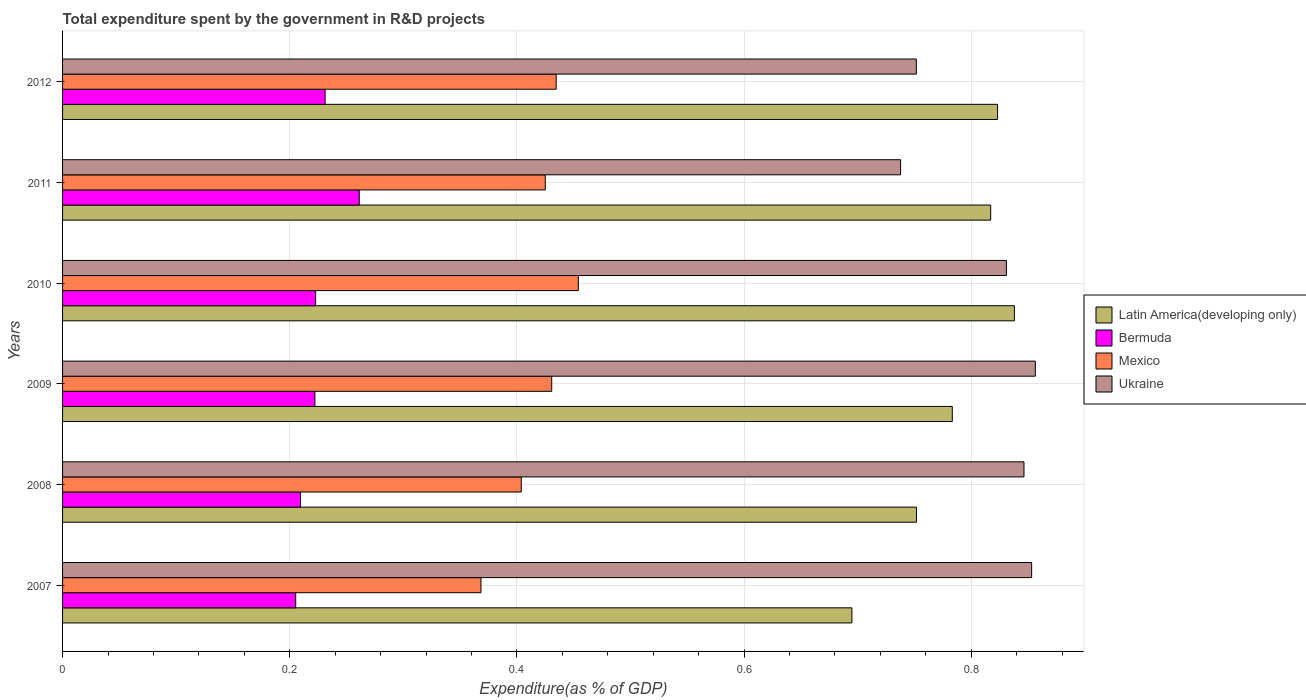How many different coloured bars are there?
Ensure brevity in your answer.  4. How many groups of bars are there?
Make the answer very short. 6. Are the number of bars per tick equal to the number of legend labels?
Offer a terse response. Yes. How many bars are there on the 3rd tick from the top?
Offer a terse response. 4. What is the total expenditure spent by the government in R&D projects in Mexico in 2011?
Your answer should be compact. 0.42. Across all years, what is the maximum total expenditure spent by the government in R&D projects in Mexico?
Your response must be concise. 0.45. Across all years, what is the minimum total expenditure spent by the government in R&D projects in Latin America(developing only)?
Your answer should be compact. 0.69. In which year was the total expenditure spent by the government in R&D projects in Mexico minimum?
Give a very brief answer. 2007. What is the total total expenditure spent by the government in R&D projects in Ukraine in the graph?
Keep it short and to the point. 4.88. What is the difference between the total expenditure spent by the government in R&D projects in Ukraine in 2009 and that in 2011?
Offer a terse response. 0.12. What is the difference between the total expenditure spent by the government in R&D projects in Mexico in 2007 and the total expenditure spent by the government in R&D projects in Ukraine in 2012?
Your response must be concise. -0.38. What is the average total expenditure spent by the government in R&D projects in Mexico per year?
Ensure brevity in your answer.  0.42. In the year 2008, what is the difference between the total expenditure spent by the government in R&D projects in Bermuda and total expenditure spent by the government in R&D projects in Latin America(developing only)?
Your answer should be compact. -0.54. In how many years, is the total expenditure spent by the government in R&D projects in Latin America(developing only) greater than 0.36 %?
Give a very brief answer. 6. What is the ratio of the total expenditure spent by the government in R&D projects in Ukraine in 2009 to that in 2011?
Your answer should be very brief. 1.16. Is the total expenditure spent by the government in R&D projects in Latin America(developing only) in 2007 less than that in 2008?
Your answer should be very brief. Yes. Is the difference between the total expenditure spent by the government in R&D projects in Bermuda in 2007 and 2008 greater than the difference between the total expenditure spent by the government in R&D projects in Latin America(developing only) in 2007 and 2008?
Offer a terse response. Yes. What is the difference between the highest and the second highest total expenditure spent by the government in R&D projects in Ukraine?
Your response must be concise. 0. What is the difference between the highest and the lowest total expenditure spent by the government in R&D projects in Mexico?
Your response must be concise. 0.09. In how many years, is the total expenditure spent by the government in R&D projects in Bermuda greater than the average total expenditure spent by the government in R&D projects in Bermuda taken over all years?
Make the answer very short. 2. Is it the case that in every year, the sum of the total expenditure spent by the government in R&D projects in Bermuda and total expenditure spent by the government in R&D projects in Latin America(developing only) is greater than the sum of total expenditure spent by the government in R&D projects in Ukraine and total expenditure spent by the government in R&D projects in Mexico?
Provide a short and direct response. No. What does the 2nd bar from the top in 2008 represents?
Make the answer very short. Mexico. What does the 2nd bar from the bottom in 2008 represents?
Your answer should be compact. Bermuda. Is it the case that in every year, the sum of the total expenditure spent by the government in R&D projects in Bermuda and total expenditure spent by the government in R&D projects in Latin America(developing only) is greater than the total expenditure spent by the government in R&D projects in Mexico?
Give a very brief answer. Yes. How many bars are there?
Give a very brief answer. 24. Are all the bars in the graph horizontal?
Provide a short and direct response. Yes. How many years are there in the graph?
Provide a short and direct response. 6. Are the values on the major ticks of X-axis written in scientific E-notation?
Your answer should be compact. No. Does the graph contain any zero values?
Provide a short and direct response. No. How many legend labels are there?
Offer a terse response. 4. How are the legend labels stacked?
Your response must be concise. Vertical. What is the title of the graph?
Make the answer very short. Total expenditure spent by the government in R&D projects. What is the label or title of the X-axis?
Make the answer very short. Expenditure(as % of GDP). What is the Expenditure(as % of GDP) of Latin America(developing only) in 2007?
Provide a succinct answer. 0.69. What is the Expenditure(as % of GDP) of Bermuda in 2007?
Ensure brevity in your answer.  0.21. What is the Expenditure(as % of GDP) in Mexico in 2007?
Keep it short and to the point. 0.37. What is the Expenditure(as % of GDP) of Ukraine in 2007?
Offer a very short reply. 0.85. What is the Expenditure(as % of GDP) of Latin America(developing only) in 2008?
Your response must be concise. 0.75. What is the Expenditure(as % of GDP) in Bermuda in 2008?
Ensure brevity in your answer.  0.21. What is the Expenditure(as % of GDP) of Mexico in 2008?
Provide a short and direct response. 0.4. What is the Expenditure(as % of GDP) in Ukraine in 2008?
Offer a very short reply. 0.85. What is the Expenditure(as % of GDP) of Latin America(developing only) in 2009?
Provide a succinct answer. 0.78. What is the Expenditure(as % of GDP) in Bermuda in 2009?
Keep it short and to the point. 0.22. What is the Expenditure(as % of GDP) of Mexico in 2009?
Make the answer very short. 0.43. What is the Expenditure(as % of GDP) of Ukraine in 2009?
Provide a succinct answer. 0.86. What is the Expenditure(as % of GDP) in Latin America(developing only) in 2010?
Give a very brief answer. 0.84. What is the Expenditure(as % of GDP) of Bermuda in 2010?
Make the answer very short. 0.22. What is the Expenditure(as % of GDP) of Mexico in 2010?
Provide a short and direct response. 0.45. What is the Expenditure(as % of GDP) in Ukraine in 2010?
Make the answer very short. 0.83. What is the Expenditure(as % of GDP) of Latin America(developing only) in 2011?
Your response must be concise. 0.82. What is the Expenditure(as % of GDP) in Bermuda in 2011?
Keep it short and to the point. 0.26. What is the Expenditure(as % of GDP) of Mexico in 2011?
Your response must be concise. 0.42. What is the Expenditure(as % of GDP) of Ukraine in 2011?
Your answer should be compact. 0.74. What is the Expenditure(as % of GDP) of Latin America(developing only) in 2012?
Provide a short and direct response. 0.82. What is the Expenditure(as % of GDP) of Bermuda in 2012?
Your answer should be compact. 0.23. What is the Expenditure(as % of GDP) in Mexico in 2012?
Your answer should be compact. 0.43. What is the Expenditure(as % of GDP) of Ukraine in 2012?
Ensure brevity in your answer.  0.75. Across all years, what is the maximum Expenditure(as % of GDP) of Latin America(developing only)?
Keep it short and to the point. 0.84. Across all years, what is the maximum Expenditure(as % of GDP) in Bermuda?
Keep it short and to the point. 0.26. Across all years, what is the maximum Expenditure(as % of GDP) of Mexico?
Keep it short and to the point. 0.45. Across all years, what is the maximum Expenditure(as % of GDP) of Ukraine?
Make the answer very short. 0.86. Across all years, what is the minimum Expenditure(as % of GDP) in Latin America(developing only)?
Offer a very short reply. 0.69. Across all years, what is the minimum Expenditure(as % of GDP) in Bermuda?
Make the answer very short. 0.21. Across all years, what is the minimum Expenditure(as % of GDP) in Mexico?
Make the answer very short. 0.37. Across all years, what is the minimum Expenditure(as % of GDP) of Ukraine?
Make the answer very short. 0.74. What is the total Expenditure(as % of GDP) of Latin America(developing only) in the graph?
Ensure brevity in your answer.  4.71. What is the total Expenditure(as % of GDP) of Bermuda in the graph?
Offer a terse response. 1.35. What is the total Expenditure(as % of GDP) of Mexico in the graph?
Ensure brevity in your answer.  2.52. What is the total Expenditure(as % of GDP) in Ukraine in the graph?
Offer a terse response. 4.88. What is the difference between the Expenditure(as % of GDP) of Latin America(developing only) in 2007 and that in 2008?
Offer a very short reply. -0.06. What is the difference between the Expenditure(as % of GDP) of Bermuda in 2007 and that in 2008?
Make the answer very short. -0. What is the difference between the Expenditure(as % of GDP) of Mexico in 2007 and that in 2008?
Provide a short and direct response. -0.04. What is the difference between the Expenditure(as % of GDP) of Ukraine in 2007 and that in 2008?
Provide a succinct answer. 0.01. What is the difference between the Expenditure(as % of GDP) in Latin America(developing only) in 2007 and that in 2009?
Offer a terse response. -0.09. What is the difference between the Expenditure(as % of GDP) of Bermuda in 2007 and that in 2009?
Provide a succinct answer. -0.02. What is the difference between the Expenditure(as % of GDP) of Mexico in 2007 and that in 2009?
Ensure brevity in your answer.  -0.06. What is the difference between the Expenditure(as % of GDP) in Ukraine in 2007 and that in 2009?
Ensure brevity in your answer.  -0. What is the difference between the Expenditure(as % of GDP) in Latin America(developing only) in 2007 and that in 2010?
Offer a very short reply. -0.14. What is the difference between the Expenditure(as % of GDP) in Bermuda in 2007 and that in 2010?
Make the answer very short. -0.02. What is the difference between the Expenditure(as % of GDP) in Mexico in 2007 and that in 2010?
Offer a terse response. -0.09. What is the difference between the Expenditure(as % of GDP) of Ukraine in 2007 and that in 2010?
Give a very brief answer. 0.02. What is the difference between the Expenditure(as % of GDP) in Latin America(developing only) in 2007 and that in 2011?
Your answer should be very brief. -0.12. What is the difference between the Expenditure(as % of GDP) of Bermuda in 2007 and that in 2011?
Keep it short and to the point. -0.06. What is the difference between the Expenditure(as % of GDP) of Mexico in 2007 and that in 2011?
Ensure brevity in your answer.  -0.06. What is the difference between the Expenditure(as % of GDP) in Ukraine in 2007 and that in 2011?
Offer a terse response. 0.12. What is the difference between the Expenditure(as % of GDP) of Latin America(developing only) in 2007 and that in 2012?
Make the answer very short. -0.13. What is the difference between the Expenditure(as % of GDP) of Bermuda in 2007 and that in 2012?
Keep it short and to the point. -0.03. What is the difference between the Expenditure(as % of GDP) of Mexico in 2007 and that in 2012?
Ensure brevity in your answer.  -0.07. What is the difference between the Expenditure(as % of GDP) of Ukraine in 2007 and that in 2012?
Make the answer very short. 0.1. What is the difference between the Expenditure(as % of GDP) of Latin America(developing only) in 2008 and that in 2009?
Provide a short and direct response. -0.03. What is the difference between the Expenditure(as % of GDP) of Bermuda in 2008 and that in 2009?
Provide a short and direct response. -0.01. What is the difference between the Expenditure(as % of GDP) in Mexico in 2008 and that in 2009?
Provide a succinct answer. -0.03. What is the difference between the Expenditure(as % of GDP) in Ukraine in 2008 and that in 2009?
Provide a succinct answer. -0.01. What is the difference between the Expenditure(as % of GDP) of Latin America(developing only) in 2008 and that in 2010?
Your answer should be compact. -0.09. What is the difference between the Expenditure(as % of GDP) in Bermuda in 2008 and that in 2010?
Offer a very short reply. -0.01. What is the difference between the Expenditure(as % of GDP) of Mexico in 2008 and that in 2010?
Make the answer very short. -0.05. What is the difference between the Expenditure(as % of GDP) of Ukraine in 2008 and that in 2010?
Offer a very short reply. 0.02. What is the difference between the Expenditure(as % of GDP) in Latin America(developing only) in 2008 and that in 2011?
Make the answer very short. -0.07. What is the difference between the Expenditure(as % of GDP) in Bermuda in 2008 and that in 2011?
Your response must be concise. -0.05. What is the difference between the Expenditure(as % of GDP) of Mexico in 2008 and that in 2011?
Your response must be concise. -0.02. What is the difference between the Expenditure(as % of GDP) of Ukraine in 2008 and that in 2011?
Make the answer very short. 0.11. What is the difference between the Expenditure(as % of GDP) in Latin America(developing only) in 2008 and that in 2012?
Your response must be concise. -0.07. What is the difference between the Expenditure(as % of GDP) of Bermuda in 2008 and that in 2012?
Your answer should be very brief. -0.02. What is the difference between the Expenditure(as % of GDP) of Mexico in 2008 and that in 2012?
Your response must be concise. -0.03. What is the difference between the Expenditure(as % of GDP) of Ukraine in 2008 and that in 2012?
Ensure brevity in your answer.  0.09. What is the difference between the Expenditure(as % of GDP) in Latin America(developing only) in 2009 and that in 2010?
Provide a short and direct response. -0.05. What is the difference between the Expenditure(as % of GDP) in Bermuda in 2009 and that in 2010?
Offer a terse response. -0. What is the difference between the Expenditure(as % of GDP) in Mexico in 2009 and that in 2010?
Your answer should be compact. -0.02. What is the difference between the Expenditure(as % of GDP) of Ukraine in 2009 and that in 2010?
Keep it short and to the point. 0.03. What is the difference between the Expenditure(as % of GDP) in Latin America(developing only) in 2009 and that in 2011?
Offer a very short reply. -0.03. What is the difference between the Expenditure(as % of GDP) of Bermuda in 2009 and that in 2011?
Make the answer very short. -0.04. What is the difference between the Expenditure(as % of GDP) in Mexico in 2009 and that in 2011?
Ensure brevity in your answer.  0.01. What is the difference between the Expenditure(as % of GDP) of Ukraine in 2009 and that in 2011?
Keep it short and to the point. 0.12. What is the difference between the Expenditure(as % of GDP) in Latin America(developing only) in 2009 and that in 2012?
Make the answer very short. -0.04. What is the difference between the Expenditure(as % of GDP) in Bermuda in 2009 and that in 2012?
Give a very brief answer. -0.01. What is the difference between the Expenditure(as % of GDP) in Mexico in 2009 and that in 2012?
Provide a succinct answer. -0. What is the difference between the Expenditure(as % of GDP) in Ukraine in 2009 and that in 2012?
Your answer should be compact. 0.1. What is the difference between the Expenditure(as % of GDP) in Latin America(developing only) in 2010 and that in 2011?
Give a very brief answer. 0.02. What is the difference between the Expenditure(as % of GDP) of Bermuda in 2010 and that in 2011?
Ensure brevity in your answer.  -0.04. What is the difference between the Expenditure(as % of GDP) of Mexico in 2010 and that in 2011?
Keep it short and to the point. 0.03. What is the difference between the Expenditure(as % of GDP) of Ukraine in 2010 and that in 2011?
Give a very brief answer. 0.09. What is the difference between the Expenditure(as % of GDP) of Latin America(developing only) in 2010 and that in 2012?
Ensure brevity in your answer.  0.01. What is the difference between the Expenditure(as % of GDP) of Bermuda in 2010 and that in 2012?
Your answer should be compact. -0.01. What is the difference between the Expenditure(as % of GDP) of Mexico in 2010 and that in 2012?
Give a very brief answer. 0.02. What is the difference between the Expenditure(as % of GDP) of Ukraine in 2010 and that in 2012?
Keep it short and to the point. 0.08. What is the difference between the Expenditure(as % of GDP) of Latin America(developing only) in 2011 and that in 2012?
Offer a terse response. -0.01. What is the difference between the Expenditure(as % of GDP) in Bermuda in 2011 and that in 2012?
Make the answer very short. 0.03. What is the difference between the Expenditure(as % of GDP) in Mexico in 2011 and that in 2012?
Ensure brevity in your answer.  -0.01. What is the difference between the Expenditure(as % of GDP) of Ukraine in 2011 and that in 2012?
Provide a short and direct response. -0.01. What is the difference between the Expenditure(as % of GDP) in Latin America(developing only) in 2007 and the Expenditure(as % of GDP) in Bermuda in 2008?
Your answer should be compact. 0.49. What is the difference between the Expenditure(as % of GDP) of Latin America(developing only) in 2007 and the Expenditure(as % of GDP) of Mexico in 2008?
Your answer should be compact. 0.29. What is the difference between the Expenditure(as % of GDP) of Latin America(developing only) in 2007 and the Expenditure(as % of GDP) of Ukraine in 2008?
Provide a short and direct response. -0.15. What is the difference between the Expenditure(as % of GDP) in Bermuda in 2007 and the Expenditure(as % of GDP) in Mexico in 2008?
Ensure brevity in your answer.  -0.2. What is the difference between the Expenditure(as % of GDP) of Bermuda in 2007 and the Expenditure(as % of GDP) of Ukraine in 2008?
Your answer should be very brief. -0.64. What is the difference between the Expenditure(as % of GDP) of Mexico in 2007 and the Expenditure(as % of GDP) of Ukraine in 2008?
Offer a very short reply. -0.48. What is the difference between the Expenditure(as % of GDP) in Latin America(developing only) in 2007 and the Expenditure(as % of GDP) in Bermuda in 2009?
Keep it short and to the point. 0.47. What is the difference between the Expenditure(as % of GDP) in Latin America(developing only) in 2007 and the Expenditure(as % of GDP) in Mexico in 2009?
Offer a very short reply. 0.26. What is the difference between the Expenditure(as % of GDP) in Latin America(developing only) in 2007 and the Expenditure(as % of GDP) in Ukraine in 2009?
Give a very brief answer. -0.16. What is the difference between the Expenditure(as % of GDP) of Bermuda in 2007 and the Expenditure(as % of GDP) of Mexico in 2009?
Your response must be concise. -0.23. What is the difference between the Expenditure(as % of GDP) of Bermuda in 2007 and the Expenditure(as % of GDP) of Ukraine in 2009?
Provide a short and direct response. -0.65. What is the difference between the Expenditure(as % of GDP) in Mexico in 2007 and the Expenditure(as % of GDP) in Ukraine in 2009?
Your answer should be very brief. -0.49. What is the difference between the Expenditure(as % of GDP) of Latin America(developing only) in 2007 and the Expenditure(as % of GDP) of Bermuda in 2010?
Your answer should be very brief. 0.47. What is the difference between the Expenditure(as % of GDP) in Latin America(developing only) in 2007 and the Expenditure(as % of GDP) in Mexico in 2010?
Provide a short and direct response. 0.24. What is the difference between the Expenditure(as % of GDP) of Latin America(developing only) in 2007 and the Expenditure(as % of GDP) of Ukraine in 2010?
Provide a short and direct response. -0.14. What is the difference between the Expenditure(as % of GDP) in Bermuda in 2007 and the Expenditure(as % of GDP) in Mexico in 2010?
Your response must be concise. -0.25. What is the difference between the Expenditure(as % of GDP) of Bermuda in 2007 and the Expenditure(as % of GDP) of Ukraine in 2010?
Make the answer very short. -0.63. What is the difference between the Expenditure(as % of GDP) of Mexico in 2007 and the Expenditure(as % of GDP) of Ukraine in 2010?
Provide a short and direct response. -0.46. What is the difference between the Expenditure(as % of GDP) of Latin America(developing only) in 2007 and the Expenditure(as % of GDP) of Bermuda in 2011?
Keep it short and to the point. 0.43. What is the difference between the Expenditure(as % of GDP) in Latin America(developing only) in 2007 and the Expenditure(as % of GDP) in Mexico in 2011?
Keep it short and to the point. 0.27. What is the difference between the Expenditure(as % of GDP) of Latin America(developing only) in 2007 and the Expenditure(as % of GDP) of Ukraine in 2011?
Give a very brief answer. -0.04. What is the difference between the Expenditure(as % of GDP) of Bermuda in 2007 and the Expenditure(as % of GDP) of Mexico in 2011?
Your answer should be very brief. -0.22. What is the difference between the Expenditure(as % of GDP) in Bermuda in 2007 and the Expenditure(as % of GDP) in Ukraine in 2011?
Provide a succinct answer. -0.53. What is the difference between the Expenditure(as % of GDP) of Mexico in 2007 and the Expenditure(as % of GDP) of Ukraine in 2011?
Your answer should be compact. -0.37. What is the difference between the Expenditure(as % of GDP) in Latin America(developing only) in 2007 and the Expenditure(as % of GDP) in Bermuda in 2012?
Provide a short and direct response. 0.46. What is the difference between the Expenditure(as % of GDP) in Latin America(developing only) in 2007 and the Expenditure(as % of GDP) in Mexico in 2012?
Your answer should be compact. 0.26. What is the difference between the Expenditure(as % of GDP) of Latin America(developing only) in 2007 and the Expenditure(as % of GDP) of Ukraine in 2012?
Offer a very short reply. -0.06. What is the difference between the Expenditure(as % of GDP) of Bermuda in 2007 and the Expenditure(as % of GDP) of Mexico in 2012?
Make the answer very short. -0.23. What is the difference between the Expenditure(as % of GDP) of Bermuda in 2007 and the Expenditure(as % of GDP) of Ukraine in 2012?
Make the answer very short. -0.55. What is the difference between the Expenditure(as % of GDP) of Mexico in 2007 and the Expenditure(as % of GDP) of Ukraine in 2012?
Ensure brevity in your answer.  -0.38. What is the difference between the Expenditure(as % of GDP) of Latin America(developing only) in 2008 and the Expenditure(as % of GDP) of Bermuda in 2009?
Provide a succinct answer. 0.53. What is the difference between the Expenditure(as % of GDP) of Latin America(developing only) in 2008 and the Expenditure(as % of GDP) of Mexico in 2009?
Keep it short and to the point. 0.32. What is the difference between the Expenditure(as % of GDP) in Latin America(developing only) in 2008 and the Expenditure(as % of GDP) in Ukraine in 2009?
Give a very brief answer. -0.1. What is the difference between the Expenditure(as % of GDP) in Bermuda in 2008 and the Expenditure(as % of GDP) in Mexico in 2009?
Your response must be concise. -0.22. What is the difference between the Expenditure(as % of GDP) of Bermuda in 2008 and the Expenditure(as % of GDP) of Ukraine in 2009?
Provide a short and direct response. -0.65. What is the difference between the Expenditure(as % of GDP) of Mexico in 2008 and the Expenditure(as % of GDP) of Ukraine in 2009?
Your answer should be compact. -0.45. What is the difference between the Expenditure(as % of GDP) in Latin America(developing only) in 2008 and the Expenditure(as % of GDP) in Bermuda in 2010?
Keep it short and to the point. 0.53. What is the difference between the Expenditure(as % of GDP) of Latin America(developing only) in 2008 and the Expenditure(as % of GDP) of Mexico in 2010?
Make the answer very short. 0.3. What is the difference between the Expenditure(as % of GDP) in Latin America(developing only) in 2008 and the Expenditure(as % of GDP) in Ukraine in 2010?
Offer a very short reply. -0.08. What is the difference between the Expenditure(as % of GDP) of Bermuda in 2008 and the Expenditure(as % of GDP) of Mexico in 2010?
Keep it short and to the point. -0.24. What is the difference between the Expenditure(as % of GDP) of Bermuda in 2008 and the Expenditure(as % of GDP) of Ukraine in 2010?
Give a very brief answer. -0.62. What is the difference between the Expenditure(as % of GDP) of Mexico in 2008 and the Expenditure(as % of GDP) of Ukraine in 2010?
Offer a very short reply. -0.43. What is the difference between the Expenditure(as % of GDP) of Latin America(developing only) in 2008 and the Expenditure(as % of GDP) of Bermuda in 2011?
Provide a short and direct response. 0.49. What is the difference between the Expenditure(as % of GDP) in Latin America(developing only) in 2008 and the Expenditure(as % of GDP) in Mexico in 2011?
Offer a terse response. 0.33. What is the difference between the Expenditure(as % of GDP) in Latin America(developing only) in 2008 and the Expenditure(as % of GDP) in Ukraine in 2011?
Your answer should be compact. 0.01. What is the difference between the Expenditure(as % of GDP) in Bermuda in 2008 and the Expenditure(as % of GDP) in Mexico in 2011?
Offer a terse response. -0.22. What is the difference between the Expenditure(as % of GDP) of Bermuda in 2008 and the Expenditure(as % of GDP) of Ukraine in 2011?
Provide a succinct answer. -0.53. What is the difference between the Expenditure(as % of GDP) of Mexico in 2008 and the Expenditure(as % of GDP) of Ukraine in 2011?
Your answer should be very brief. -0.33. What is the difference between the Expenditure(as % of GDP) in Latin America(developing only) in 2008 and the Expenditure(as % of GDP) in Bermuda in 2012?
Give a very brief answer. 0.52. What is the difference between the Expenditure(as % of GDP) of Latin America(developing only) in 2008 and the Expenditure(as % of GDP) of Mexico in 2012?
Offer a terse response. 0.32. What is the difference between the Expenditure(as % of GDP) of Bermuda in 2008 and the Expenditure(as % of GDP) of Mexico in 2012?
Provide a short and direct response. -0.23. What is the difference between the Expenditure(as % of GDP) in Bermuda in 2008 and the Expenditure(as % of GDP) in Ukraine in 2012?
Provide a short and direct response. -0.54. What is the difference between the Expenditure(as % of GDP) in Mexico in 2008 and the Expenditure(as % of GDP) in Ukraine in 2012?
Provide a short and direct response. -0.35. What is the difference between the Expenditure(as % of GDP) of Latin America(developing only) in 2009 and the Expenditure(as % of GDP) of Bermuda in 2010?
Offer a terse response. 0.56. What is the difference between the Expenditure(as % of GDP) in Latin America(developing only) in 2009 and the Expenditure(as % of GDP) in Mexico in 2010?
Make the answer very short. 0.33. What is the difference between the Expenditure(as % of GDP) in Latin America(developing only) in 2009 and the Expenditure(as % of GDP) in Ukraine in 2010?
Your response must be concise. -0.05. What is the difference between the Expenditure(as % of GDP) of Bermuda in 2009 and the Expenditure(as % of GDP) of Mexico in 2010?
Provide a succinct answer. -0.23. What is the difference between the Expenditure(as % of GDP) of Bermuda in 2009 and the Expenditure(as % of GDP) of Ukraine in 2010?
Offer a terse response. -0.61. What is the difference between the Expenditure(as % of GDP) in Mexico in 2009 and the Expenditure(as % of GDP) in Ukraine in 2010?
Offer a very short reply. -0.4. What is the difference between the Expenditure(as % of GDP) in Latin America(developing only) in 2009 and the Expenditure(as % of GDP) in Bermuda in 2011?
Provide a short and direct response. 0.52. What is the difference between the Expenditure(as % of GDP) of Latin America(developing only) in 2009 and the Expenditure(as % of GDP) of Mexico in 2011?
Keep it short and to the point. 0.36. What is the difference between the Expenditure(as % of GDP) in Latin America(developing only) in 2009 and the Expenditure(as % of GDP) in Ukraine in 2011?
Offer a terse response. 0.05. What is the difference between the Expenditure(as % of GDP) in Bermuda in 2009 and the Expenditure(as % of GDP) in Mexico in 2011?
Give a very brief answer. -0.2. What is the difference between the Expenditure(as % of GDP) in Bermuda in 2009 and the Expenditure(as % of GDP) in Ukraine in 2011?
Offer a terse response. -0.52. What is the difference between the Expenditure(as % of GDP) in Mexico in 2009 and the Expenditure(as % of GDP) in Ukraine in 2011?
Ensure brevity in your answer.  -0.31. What is the difference between the Expenditure(as % of GDP) in Latin America(developing only) in 2009 and the Expenditure(as % of GDP) in Bermuda in 2012?
Keep it short and to the point. 0.55. What is the difference between the Expenditure(as % of GDP) of Latin America(developing only) in 2009 and the Expenditure(as % of GDP) of Mexico in 2012?
Your answer should be very brief. 0.35. What is the difference between the Expenditure(as % of GDP) of Latin America(developing only) in 2009 and the Expenditure(as % of GDP) of Ukraine in 2012?
Make the answer very short. 0.03. What is the difference between the Expenditure(as % of GDP) in Bermuda in 2009 and the Expenditure(as % of GDP) in Mexico in 2012?
Your response must be concise. -0.21. What is the difference between the Expenditure(as % of GDP) of Bermuda in 2009 and the Expenditure(as % of GDP) of Ukraine in 2012?
Give a very brief answer. -0.53. What is the difference between the Expenditure(as % of GDP) in Mexico in 2009 and the Expenditure(as % of GDP) in Ukraine in 2012?
Give a very brief answer. -0.32. What is the difference between the Expenditure(as % of GDP) in Latin America(developing only) in 2010 and the Expenditure(as % of GDP) in Bermuda in 2011?
Give a very brief answer. 0.58. What is the difference between the Expenditure(as % of GDP) of Latin America(developing only) in 2010 and the Expenditure(as % of GDP) of Mexico in 2011?
Make the answer very short. 0.41. What is the difference between the Expenditure(as % of GDP) in Latin America(developing only) in 2010 and the Expenditure(as % of GDP) in Ukraine in 2011?
Offer a very short reply. 0.1. What is the difference between the Expenditure(as % of GDP) of Bermuda in 2010 and the Expenditure(as % of GDP) of Mexico in 2011?
Your answer should be very brief. -0.2. What is the difference between the Expenditure(as % of GDP) of Bermuda in 2010 and the Expenditure(as % of GDP) of Ukraine in 2011?
Your answer should be very brief. -0.52. What is the difference between the Expenditure(as % of GDP) in Mexico in 2010 and the Expenditure(as % of GDP) in Ukraine in 2011?
Ensure brevity in your answer.  -0.28. What is the difference between the Expenditure(as % of GDP) in Latin America(developing only) in 2010 and the Expenditure(as % of GDP) in Bermuda in 2012?
Offer a very short reply. 0.61. What is the difference between the Expenditure(as % of GDP) of Latin America(developing only) in 2010 and the Expenditure(as % of GDP) of Mexico in 2012?
Offer a terse response. 0.4. What is the difference between the Expenditure(as % of GDP) of Latin America(developing only) in 2010 and the Expenditure(as % of GDP) of Ukraine in 2012?
Provide a short and direct response. 0.09. What is the difference between the Expenditure(as % of GDP) in Bermuda in 2010 and the Expenditure(as % of GDP) in Mexico in 2012?
Your response must be concise. -0.21. What is the difference between the Expenditure(as % of GDP) of Bermuda in 2010 and the Expenditure(as % of GDP) of Ukraine in 2012?
Offer a terse response. -0.53. What is the difference between the Expenditure(as % of GDP) of Mexico in 2010 and the Expenditure(as % of GDP) of Ukraine in 2012?
Offer a terse response. -0.3. What is the difference between the Expenditure(as % of GDP) in Latin America(developing only) in 2011 and the Expenditure(as % of GDP) in Bermuda in 2012?
Your answer should be compact. 0.59. What is the difference between the Expenditure(as % of GDP) in Latin America(developing only) in 2011 and the Expenditure(as % of GDP) in Mexico in 2012?
Provide a succinct answer. 0.38. What is the difference between the Expenditure(as % of GDP) of Latin America(developing only) in 2011 and the Expenditure(as % of GDP) of Ukraine in 2012?
Make the answer very short. 0.07. What is the difference between the Expenditure(as % of GDP) in Bermuda in 2011 and the Expenditure(as % of GDP) in Mexico in 2012?
Make the answer very short. -0.17. What is the difference between the Expenditure(as % of GDP) in Bermuda in 2011 and the Expenditure(as % of GDP) in Ukraine in 2012?
Make the answer very short. -0.49. What is the difference between the Expenditure(as % of GDP) in Mexico in 2011 and the Expenditure(as % of GDP) in Ukraine in 2012?
Ensure brevity in your answer.  -0.33. What is the average Expenditure(as % of GDP) in Latin America(developing only) per year?
Make the answer very short. 0.78. What is the average Expenditure(as % of GDP) in Bermuda per year?
Provide a short and direct response. 0.23. What is the average Expenditure(as % of GDP) of Mexico per year?
Your answer should be compact. 0.42. What is the average Expenditure(as % of GDP) of Ukraine per year?
Offer a terse response. 0.81. In the year 2007, what is the difference between the Expenditure(as % of GDP) of Latin America(developing only) and Expenditure(as % of GDP) of Bermuda?
Your response must be concise. 0.49. In the year 2007, what is the difference between the Expenditure(as % of GDP) in Latin America(developing only) and Expenditure(as % of GDP) in Mexico?
Keep it short and to the point. 0.33. In the year 2007, what is the difference between the Expenditure(as % of GDP) of Latin America(developing only) and Expenditure(as % of GDP) of Ukraine?
Your answer should be compact. -0.16. In the year 2007, what is the difference between the Expenditure(as % of GDP) of Bermuda and Expenditure(as % of GDP) of Mexico?
Provide a succinct answer. -0.16. In the year 2007, what is the difference between the Expenditure(as % of GDP) in Bermuda and Expenditure(as % of GDP) in Ukraine?
Offer a very short reply. -0.65. In the year 2007, what is the difference between the Expenditure(as % of GDP) in Mexico and Expenditure(as % of GDP) in Ukraine?
Provide a short and direct response. -0.48. In the year 2008, what is the difference between the Expenditure(as % of GDP) of Latin America(developing only) and Expenditure(as % of GDP) of Bermuda?
Your response must be concise. 0.54. In the year 2008, what is the difference between the Expenditure(as % of GDP) in Latin America(developing only) and Expenditure(as % of GDP) in Mexico?
Offer a terse response. 0.35. In the year 2008, what is the difference between the Expenditure(as % of GDP) of Latin America(developing only) and Expenditure(as % of GDP) of Ukraine?
Your answer should be compact. -0.09. In the year 2008, what is the difference between the Expenditure(as % of GDP) of Bermuda and Expenditure(as % of GDP) of Mexico?
Your answer should be very brief. -0.19. In the year 2008, what is the difference between the Expenditure(as % of GDP) of Bermuda and Expenditure(as % of GDP) of Ukraine?
Provide a short and direct response. -0.64. In the year 2008, what is the difference between the Expenditure(as % of GDP) in Mexico and Expenditure(as % of GDP) in Ukraine?
Your response must be concise. -0.44. In the year 2009, what is the difference between the Expenditure(as % of GDP) in Latin America(developing only) and Expenditure(as % of GDP) in Bermuda?
Keep it short and to the point. 0.56. In the year 2009, what is the difference between the Expenditure(as % of GDP) in Latin America(developing only) and Expenditure(as % of GDP) in Mexico?
Ensure brevity in your answer.  0.35. In the year 2009, what is the difference between the Expenditure(as % of GDP) of Latin America(developing only) and Expenditure(as % of GDP) of Ukraine?
Your answer should be compact. -0.07. In the year 2009, what is the difference between the Expenditure(as % of GDP) of Bermuda and Expenditure(as % of GDP) of Mexico?
Offer a very short reply. -0.21. In the year 2009, what is the difference between the Expenditure(as % of GDP) of Bermuda and Expenditure(as % of GDP) of Ukraine?
Offer a terse response. -0.63. In the year 2009, what is the difference between the Expenditure(as % of GDP) in Mexico and Expenditure(as % of GDP) in Ukraine?
Offer a very short reply. -0.43. In the year 2010, what is the difference between the Expenditure(as % of GDP) in Latin America(developing only) and Expenditure(as % of GDP) in Bermuda?
Give a very brief answer. 0.62. In the year 2010, what is the difference between the Expenditure(as % of GDP) of Latin America(developing only) and Expenditure(as % of GDP) of Mexico?
Provide a succinct answer. 0.38. In the year 2010, what is the difference between the Expenditure(as % of GDP) of Latin America(developing only) and Expenditure(as % of GDP) of Ukraine?
Give a very brief answer. 0.01. In the year 2010, what is the difference between the Expenditure(as % of GDP) of Bermuda and Expenditure(as % of GDP) of Mexico?
Provide a succinct answer. -0.23. In the year 2010, what is the difference between the Expenditure(as % of GDP) of Bermuda and Expenditure(as % of GDP) of Ukraine?
Keep it short and to the point. -0.61. In the year 2010, what is the difference between the Expenditure(as % of GDP) of Mexico and Expenditure(as % of GDP) of Ukraine?
Provide a short and direct response. -0.38. In the year 2011, what is the difference between the Expenditure(as % of GDP) in Latin America(developing only) and Expenditure(as % of GDP) in Bermuda?
Provide a succinct answer. 0.56. In the year 2011, what is the difference between the Expenditure(as % of GDP) of Latin America(developing only) and Expenditure(as % of GDP) of Mexico?
Give a very brief answer. 0.39. In the year 2011, what is the difference between the Expenditure(as % of GDP) of Latin America(developing only) and Expenditure(as % of GDP) of Ukraine?
Ensure brevity in your answer.  0.08. In the year 2011, what is the difference between the Expenditure(as % of GDP) in Bermuda and Expenditure(as % of GDP) in Mexico?
Your answer should be compact. -0.16. In the year 2011, what is the difference between the Expenditure(as % of GDP) of Bermuda and Expenditure(as % of GDP) of Ukraine?
Give a very brief answer. -0.48. In the year 2011, what is the difference between the Expenditure(as % of GDP) in Mexico and Expenditure(as % of GDP) in Ukraine?
Ensure brevity in your answer.  -0.31. In the year 2012, what is the difference between the Expenditure(as % of GDP) of Latin America(developing only) and Expenditure(as % of GDP) of Bermuda?
Provide a short and direct response. 0.59. In the year 2012, what is the difference between the Expenditure(as % of GDP) in Latin America(developing only) and Expenditure(as % of GDP) in Mexico?
Offer a very short reply. 0.39. In the year 2012, what is the difference between the Expenditure(as % of GDP) of Latin America(developing only) and Expenditure(as % of GDP) of Ukraine?
Ensure brevity in your answer.  0.07. In the year 2012, what is the difference between the Expenditure(as % of GDP) of Bermuda and Expenditure(as % of GDP) of Mexico?
Your answer should be compact. -0.2. In the year 2012, what is the difference between the Expenditure(as % of GDP) in Bermuda and Expenditure(as % of GDP) in Ukraine?
Ensure brevity in your answer.  -0.52. In the year 2012, what is the difference between the Expenditure(as % of GDP) of Mexico and Expenditure(as % of GDP) of Ukraine?
Make the answer very short. -0.32. What is the ratio of the Expenditure(as % of GDP) of Latin America(developing only) in 2007 to that in 2008?
Provide a short and direct response. 0.92. What is the ratio of the Expenditure(as % of GDP) of Bermuda in 2007 to that in 2008?
Your answer should be very brief. 0.98. What is the ratio of the Expenditure(as % of GDP) in Mexico in 2007 to that in 2008?
Your answer should be very brief. 0.91. What is the ratio of the Expenditure(as % of GDP) in Ukraine in 2007 to that in 2008?
Offer a very short reply. 1.01. What is the ratio of the Expenditure(as % of GDP) of Latin America(developing only) in 2007 to that in 2009?
Offer a terse response. 0.89. What is the ratio of the Expenditure(as % of GDP) in Bermuda in 2007 to that in 2009?
Your answer should be compact. 0.92. What is the ratio of the Expenditure(as % of GDP) in Mexico in 2007 to that in 2009?
Offer a very short reply. 0.86. What is the ratio of the Expenditure(as % of GDP) in Latin America(developing only) in 2007 to that in 2010?
Your response must be concise. 0.83. What is the ratio of the Expenditure(as % of GDP) in Bermuda in 2007 to that in 2010?
Offer a terse response. 0.92. What is the ratio of the Expenditure(as % of GDP) of Mexico in 2007 to that in 2010?
Keep it short and to the point. 0.81. What is the ratio of the Expenditure(as % of GDP) in Ukraine in 2007 to that in 2010?
Provide a short and direct response. 1.03. What is the ratio of the Expenditure(as % of GDP) in Latin America(developing only) in 2007 to that in 2011?
Keep it short and to the point. 0.85. What is the ratio of the Expenditure(as % of GDP) of Bermuda in 2007 to that in 2011?
Your answer should be compact. 0.79. What is the ratio of the Expenditure(as % of GDP) in Mexico in 2007 to that in 2011?
Give a very brief answer. 0.87. What is the ratio of the Expenditure(as % of GDP) of Ukraine in 2007 to that in 2011?
Your answer should be very brief. 1.16. What is the ratio of the Expenditure(as % of GDP) of Latin America(developing only) in 2007 to that in 2012?
Make the answer very short. 0.84. What is the ratio of the Expenditure(as % of GDP) in Bermuda in 2007 to that in 2012?
Give a very brief answer. 0.89. What is the ratio of the Expenditure(as % of GDP) of Mexico in 2007 to that in 2012?
Your answer should be compact. 0.85. What is the ratio of the Expenditure(as % of GDP) in Ukraine in 2007 to that in 2012?
Your answer should be compact. 1.14. What is the ratio of the Expenditure(as % of GDP) in Latin America(developing only) in 2008 to that in 2009?
Ensure brevity in your answer.  0.96. What is the ratio of the Expenditure(as % of GDP) of Bermuda in 2008 to that in 2009?
Your answer should be very brief. 0.94. What is the ratio of the Expenditure(as % of GDP) of Mexico in 2008 to that in 2009?
Offer a terse response. 0.94. What is the ratio of the Expenditure(as % of GDP) of Ukraine in 2008 to that in 2009?
Give a very brief answer. 0.99. What is the ratio of the Expenditure(as % of GDP) in Latin America(developing only) in 2008 to that in 2010?
Offer a very short reply. 0.9. What is the ratio of the Expenditure(as % of GDP) in Bermuda in 2008 to that in 2010?
Offer a very short reply. 0.94. What is the ratio of the Expenditure(as % of GDP) of Mexico in 2008 to that in 2010?
Offer a very short reply. 0.89. What is the ratio of the Expenditure(as % of GDP) of Ukraine in 2008 to that in 2010?
Your response must be concise. 1.02. What is the ratio of the Expenditure(as % of GDP) of Bermuda in 2008 to that in 2011?
Your response must be concise. 0.8. What is the ratio of the Expenditure(as % of GDP) of Mexico in 2008 to that in 2011?
Provide a short and direct response. 0.95. What is the ratio of the Expenditure(as % of GDP) of Ukraine in 2008 to that in 2011?
Your response must be concise. 1.15. What is the ratio of the Expenditure(as % of GDP) in Latin America(developing only) in 2008 to that in 2012?
Offer a terse response. 0.91. What is the ratio of the Expenditure(as % of GDP) of Bermuda in 2008 to that in 2012?
Provide a succinct answer. 0.91. What is the ratio of the Expenditure(as % of GDP) of Mexico in 2008 to that in 2012?
Make the answer very short. 0.93. What is the ratio of the Expenditure(as % of GDP) in Ukraine in 2008 to that in 2012?
Your response must be concise. 1.13. What is the ratio of the Expenditure(as % of GDP) of Latin America(developing only) in 2009 to that in 2010?
Provide a succinct answer. 0.93. What is the ratio of the Expenditure(as % of GDP) of Mexico in 2009 to that in 2010?
Your response must be concise. 0.95. What is the ratio of the Expenditure(as % of GDP) of Ukraine in 2009 to that in 2010?
Ensure brevity in your answer.  1.03. What is the ratio of the Expenditure(as % of GDP) in Latin America(developing only) in 2009 to that in 2011?
Keep it short and to the point. 0.96. What is the ratio of the Expenditure(as % of GDP) in Bermuda in 2009 to that in 2011?
Your response must be concise. 0.85. What is the ratio of the Expenditure(as % of GDP) in Mexico in 2009 to that in 2011?
Your response must be concise. 1.01. What is the ratio of the Expenditure(as % of GDP) in Ukraine in 2009 to that in 2011?
Your answer should be compact. 1.16. What is the ratio of the Expenditure(as % of GDP) in Latin America(developing only) in 2009 to that in 2012?
Your answer should be very brief. 0.95. What is the ratio of the Expenditure(as % of GDP) in Bermuda in 2009 to that in 2012?
Give a very brief answer. 0.96. What is the ratio of the Expenditure(as % of GDP) in Ukraine in 2009 to that in 2012?
Make the answer very short. 1.14. What is the ratio of the Expenditure(as % of GDP) of Latin America(developing only) in 2010 to that in 2011?
Provide a succinct answer. 1.03. What is the ratio of the Expenditure(as % of GDP) of Bermuda in 2010 to that in 2011?
Make the answer very short. 0.85. What is the ratio of the Expenditure(as % of GDP) of Mexico in 2010 to that in 2011?
Provide a succinct answer. 1.07. What is the ratio of the Expenditure(as % of GDP) of Ukraine in 2010 to that in 2011?
Your answer should be compact. 1.13. What is the ratio of the Expenditure(as % of GDP) in Bermuda in 2010 to that in 2012?
Keep it short and to the point. 0.96. What is the ratio of the Expenditure(as % of GDP) in Mexico in 2010 to that in 2012?
Offer a very short reply. 1.04. What is the ratio of the Expenditure(as % of GDP) in Ukraine in 2010 to that in 2012?
Your response must be concise. 1.11. What is the ratio of the Expenditure(as % of GDP) of Bermuda in 2011 to that in 2012?
Ensure brevity in your answer.  1.13. What is the ratio of the Expenditure(as % of GDP) in Mexico in 2011 to that in 2012?
Your answer should be very brief. 0.98. What is the ratio of the Expenditure(as % of GDP) in Ukraine in 2011 to that in 2012?
Make the answer very short. 0.98. What is the difference between the highest and the second highest Expenditure(as % of GDP) in Latin America(developing only)?
Offer a very short reply. 0.01. What is the difference between the highest and the second highest Expenditure(as % of GDP) of Bermuda?
Keep it short and to the point. 0.03. What is the difference between the highest and the second highest Expenditure(as % of GDP) of Mexico?
Keep it short and to the point. 0.02. What is the difference between the highest and the second highest Expenditure(as % of GDP) in Ukraine?
Give a very brief answer. 0. What is the difference between the highest and the lowest Expenditure(as % of GDP) in Latin America(developing only)?
Provide a short and direct response. 0.14. What is the difference between the highest and the lowest Expenditure(as % of GDP) of Bermuda?
Keep it short and to the point. 0.06. What is the difference between the highest and the lowest Expenditure(as % of GDP) of Mexico?
Keep it short and to the point. 0.09. What is the difference between the highest and the lowest Expenditure(as % of GDP) in Ukraine?
Make the answer very short. 0.12. 